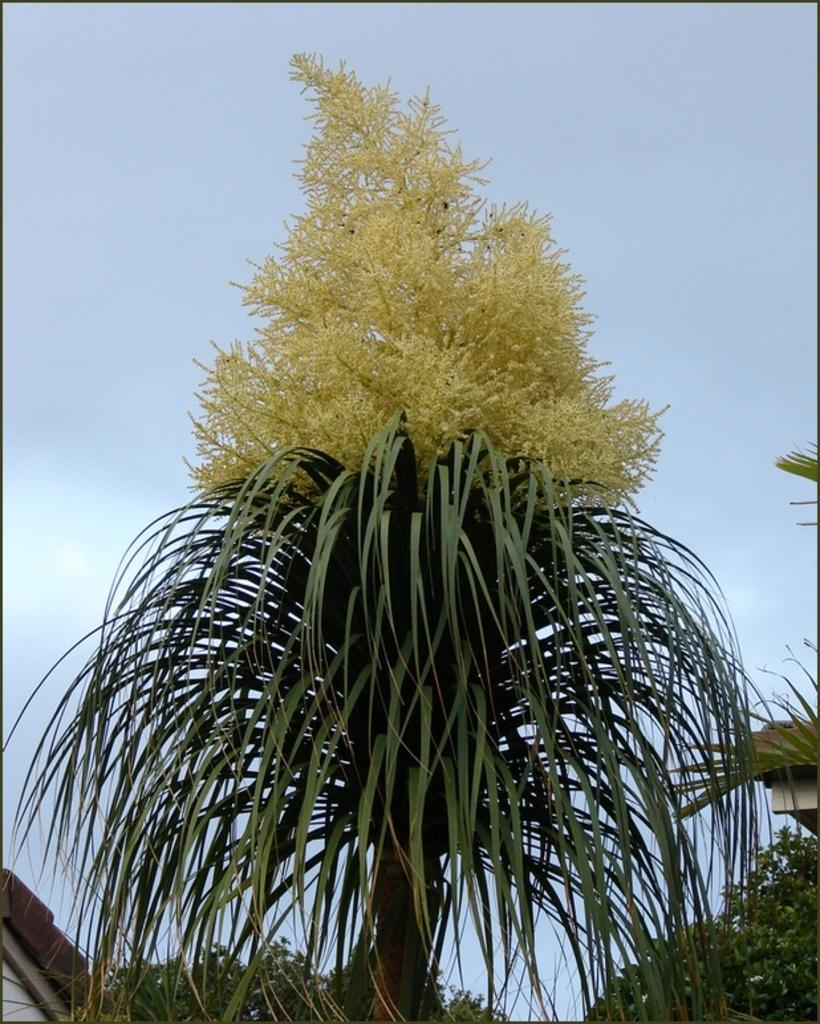What is the dog playing with in the garden? The dog is playing with a ball in the garden. What other elements can be seen in the garden? There are flowers in the garden. What type of regret can be seen in the garden? There is no regret present in the garden; it is a dog playing with a ball and flowers. How many goldfish are swimming in the vase in the garden? There is no vase or goldfish present in the garden; it features a dog playing with a ball and flowers. 